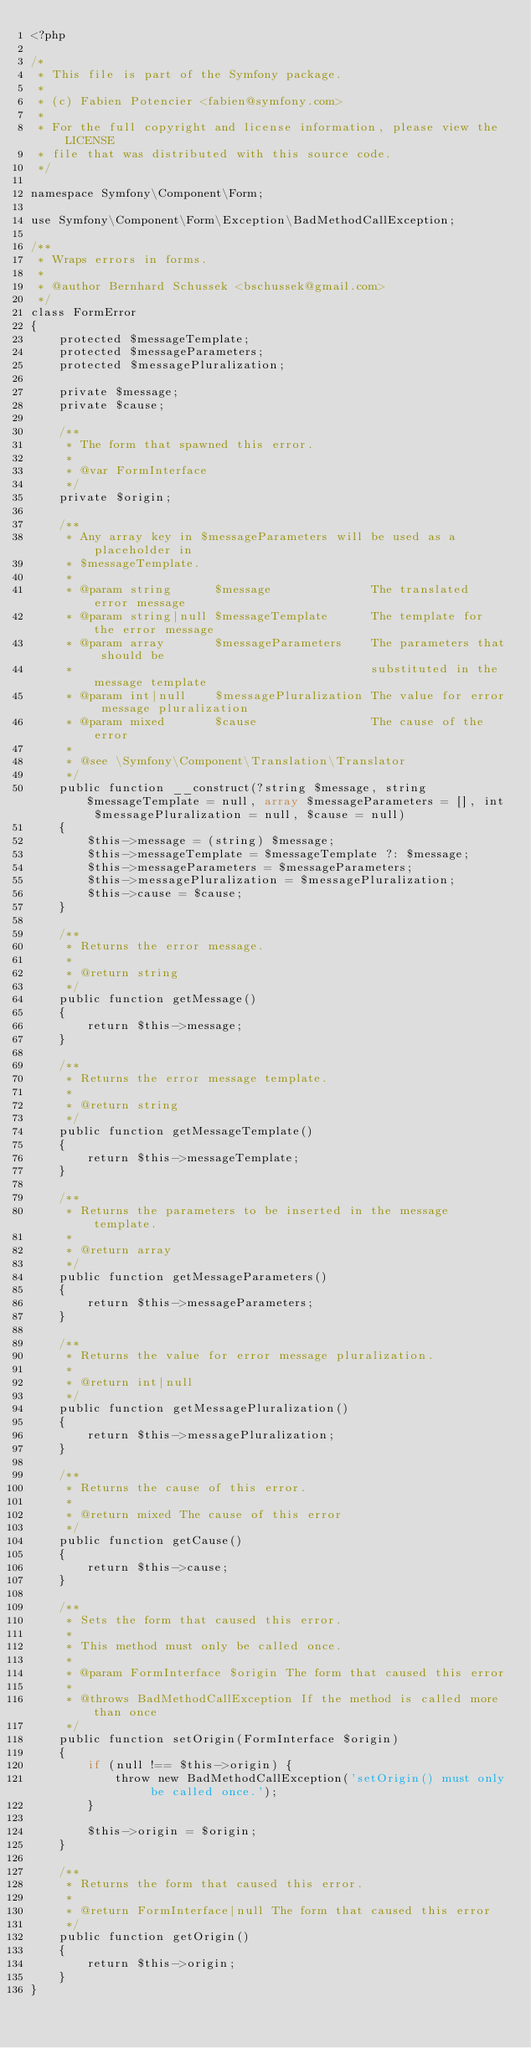Convert code to text. <code><loc_0><loc_0><loc_500><loc_500><_PHP_><?php

/*
 * This file is part of the Symfony package.
 *
 * (c) Fabien Potencier <fabien@symfony.com>
 *
 * For the full copyright and license information, please view the LICENSE
 * file that was distributed with this source code.
 */

namespace Symfony\Component\Form;

use Symfony\Component\Form\Exception\BadMethodCallException;

/**
 * Wraps errors in forms.
 *
 * @author Bernhard Schussek <bschussek@gmail.com>
 */
class FormError
{
    protected $messageTemplate;
    protected $messageParameters;
    protected $messagePluralization;

    private $message;
    private $cause;

    /**
     * The form that spawned this error.
     *
     * @var FormInterface
     */
    private $origin;

    /**
     * Any array key in $messageParameters will be used as a placeholder in
     * $messageTemplate.
     *
     * @param string      $message              The translated error message
     * @param string|null $messageTemplate      The template for the error message
     * @param array       $messageParameters    The parameters that should be
     *                                          substituted in the message template
     * @param int|null    $messagePluralization The value for error message pluralization
     * @param mixed       $cause                The cause of the error
     *
     * @see \Symfony\Component\Translation\Translator
     */
    public function __construct(?string $message, string $messageTemplate = null, array $messageParameters = [], int $messagePluralization = null, $cause = null)
    {
        $this->message = (string) $message;
        $this->messageTemplate = $messageTemplate ?: $message;
        $this->messageParameters = $messageParameters;
        $this->messagePluralization = $messagePluralization;
        $this->cause = $cause;
    }

    /**
     * Returns the error message.
     *
     * @return string
     */
    public function getMessage()
    {
        return $this->message;
    }

    /**
     * Returns the error message template.
     *
     * @return string
     */
    public function getMessageTemplate()
    {
        return $this->messageTemplate;
    }

    /**
     * Returns the parameters to be inserted in the message template.
     *
     * @return array
     */
    public function getMessageParameters()
    {
        return $this->messageParameters;
    }

    /**
     * Returns the value for error message pluralization.
     *
     * @return int|null
     */
    public function getMessagePluralization()
    {
        return $this->messagePluralization;
    }

    /**
     * Returns the cause of this error.
     *
     * @return mixed The cause of this error
     */
    public function getCause()
    {
        return $this->cause;
    }

    /**
     * Sets the form that caused this error.
     *
     * This method must only be called once.
     *
     * @param FormInterface $origin The form that caused this error
     *
     * @throws BadMethodCallException If the method is called more than once
     */
    public function setOrigin(FormInterface $origin)
    {
        if (null !== $this->origin) {
            throw new BadMethodCallException('setOrigin() must only be called once.');
        }

        $this->origin = $origin;
    }

    /**
     * Returns the form that caused this error.
     *
     * @return FormInterface|null The form that caused this error
     */
    public function getOrigin()
    {
        return $this->origin;
    }
}
</code> 